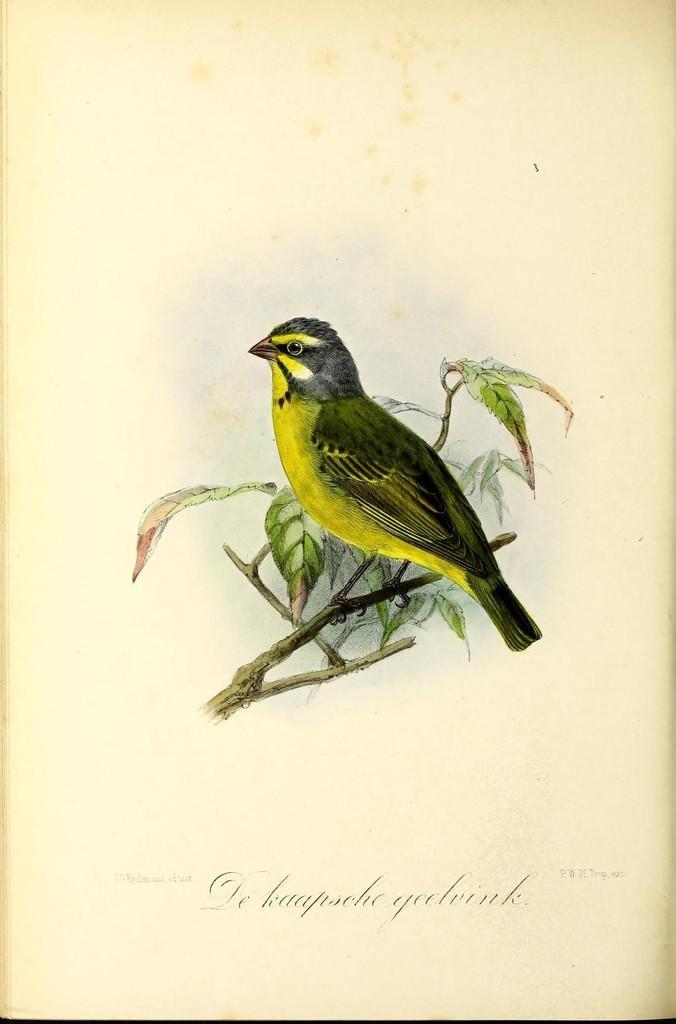Could you give a brief overview of what you see in this image? In this picture we can see a bird standing on the stem. There are leaves. At the bottom portion of the picture we can see there is something written. 